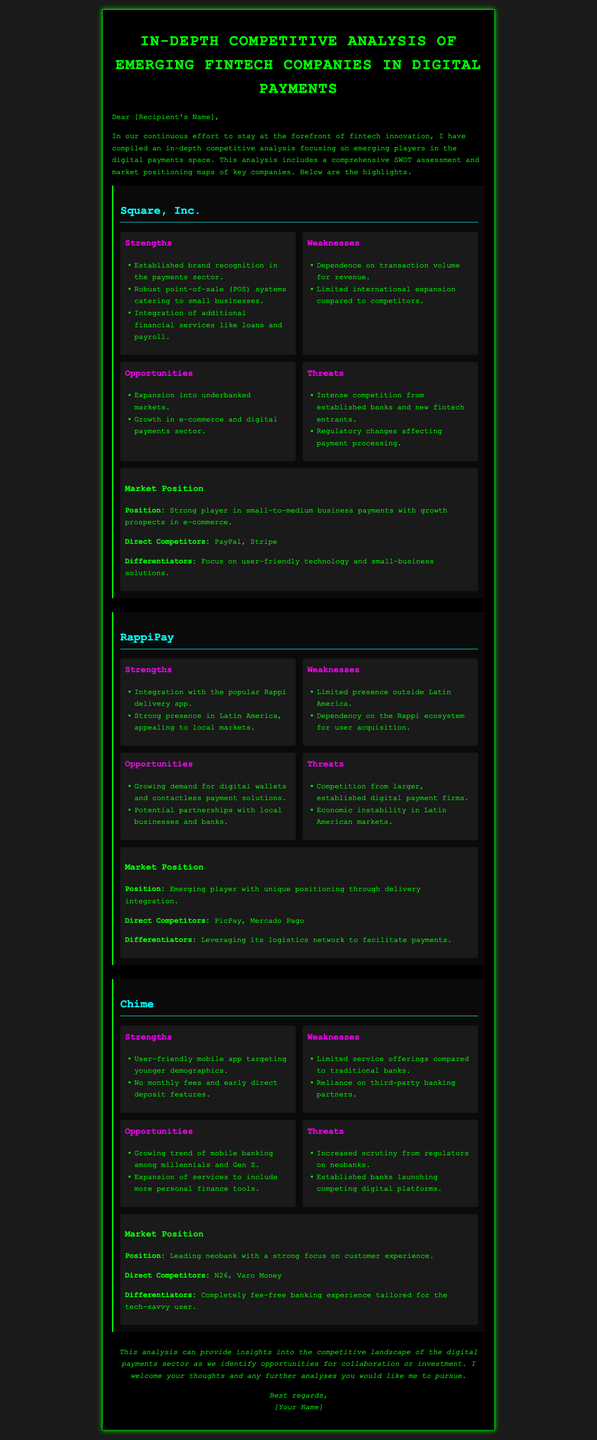What is the main focus of the competitive analysis? The competitive analysis focuses on emerging players in the digital payments space.
Answer: Emerging players in the digital payments space What company has a strong presence in Latin America? The company highlighted with a strong presence in Latin America is RappiPay.
Answer: RappiPay Which company is identified as a leading neobank? The document identifies Chime as the leading neobank.
Answer: Chime What is one of Square's weaknesses? One of Square's weaknesses is its dependence on transaction volume for revenue.
Answer: Dependence on transaction volume for revenue What differentiates Chime from traditional banks? Chime differentiates itself with a completely fee-free banking experience tailored for the tech-savvy user.
Answer: Completely fee-free banking experience What are the direct competitors of RappiPay? The direct competitors of RappiPay mentioned in the document are PicPay and Mercado Pago.
Answer: PicPay, Mercado Pago What opportunity exists for Square? An opportunity for Square is the expansion into underbanked markets.
Answer: Expansion into underbanked markets What type of document is this? This document is an in-depth competitive analysis mail.
Answer: In-depth competitive analysis mail What color is used for headings in the document? The color used for headings in the document is bright green.
Answer: Bright green 